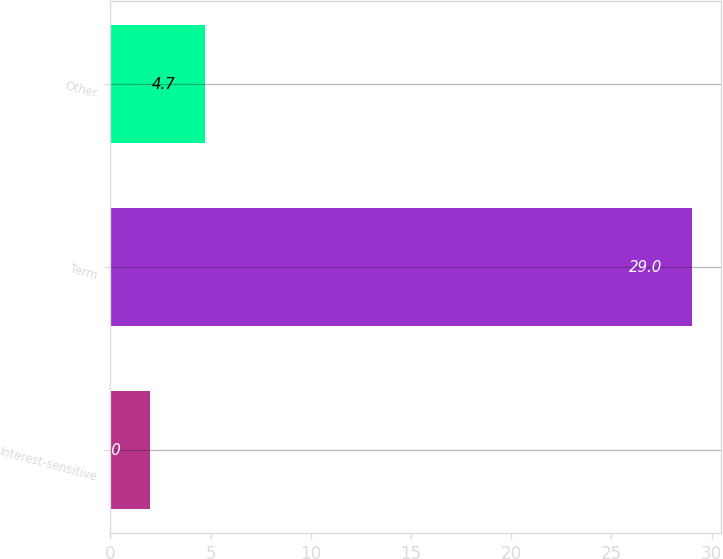Convert chart. <chart><loc_0><loc_0><loc_500><loc_500><bar_chart><fcel>Interest-sensitive<fcel>Term<fcel>Other<nl><fcel>2<fcel>29<fcel>4.7<nl></chart> 